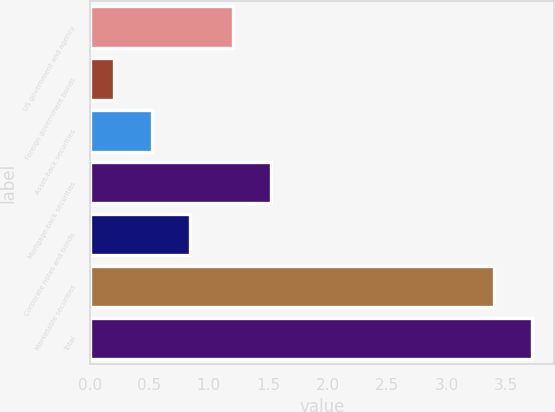Convert chart to OTSL. <chart><loc_0><loc_0><loc_500><loc_500><bar_chart><fcel>US government and agency<fcel>Foreign government bonds<fcel>Asset-back securities<fcel>Mortgage-back securities<fcel>Corporate notes and bonds<fcel>Marketable securities<fcel>Total<nl><fcel>1.2<fcel>0.2<fcel>0.52<fcel>1.52<fcel>0.84<fcel>3.4<fcel>3.72<nl></chart> 